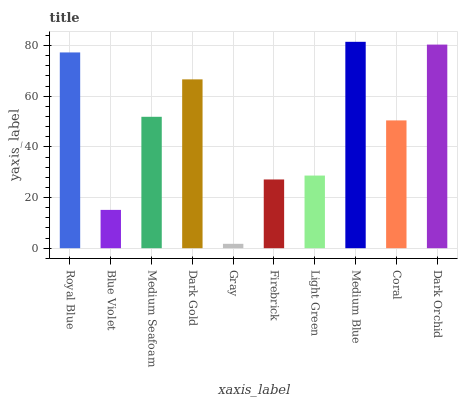Is Gray the minimum?
Answer yes or no. Yes. Is Medium Blue the maximum?
Answer yes or no. Yes. Is Blue Violet the minimum?
Answer yes or no. No. Is Blue Violet the maximum?
Answer yes or no. No. Is Royal Blue greater than Blue Violet?
Answer yes or no. Yes. Is Blue Violet less than Royal Blue?
Answer yes or no. Yes. Is Blue Violet greater than Royal Blue?
Answer yes or no. No. Is Royal Blue less than Blue Violet?
Answer yes or no. No. Is Medium Seafoam the high median?
Answer yes or no. Yes. Is Coral the low median?
Answer yes or no. Yes. Is Blue Violet the high median?
Answer yes or no. No. Is Dark Orchid the low median?
Answer yes or no. No. 